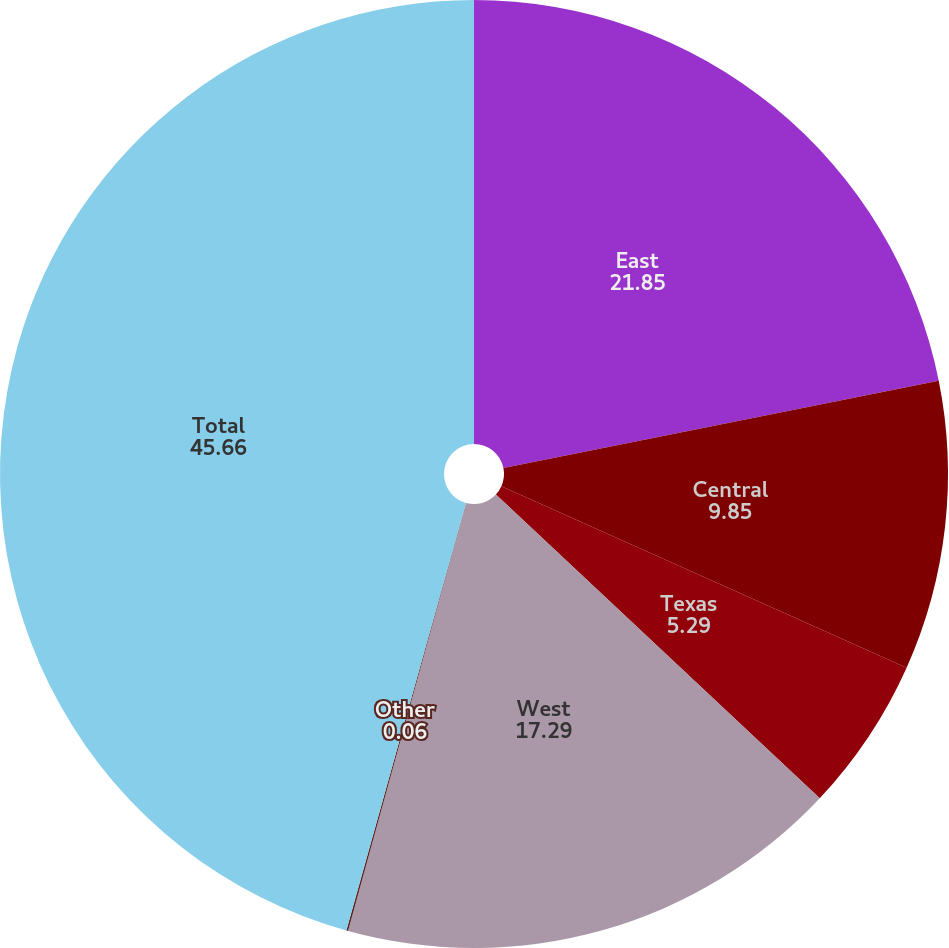<chart> <loc_0><loc_0><loc_500><loc_500><pie_chart><fcel>East<fcel>Central<fcel>Texas<fcel>West<fcel>Other<fcel>Total<nl><fcel>21.85%<fcel>9.85%<fcel>5.29%<fcel>17.29%<fcel>0.06%<fcel>45.66%<nl></chart> 